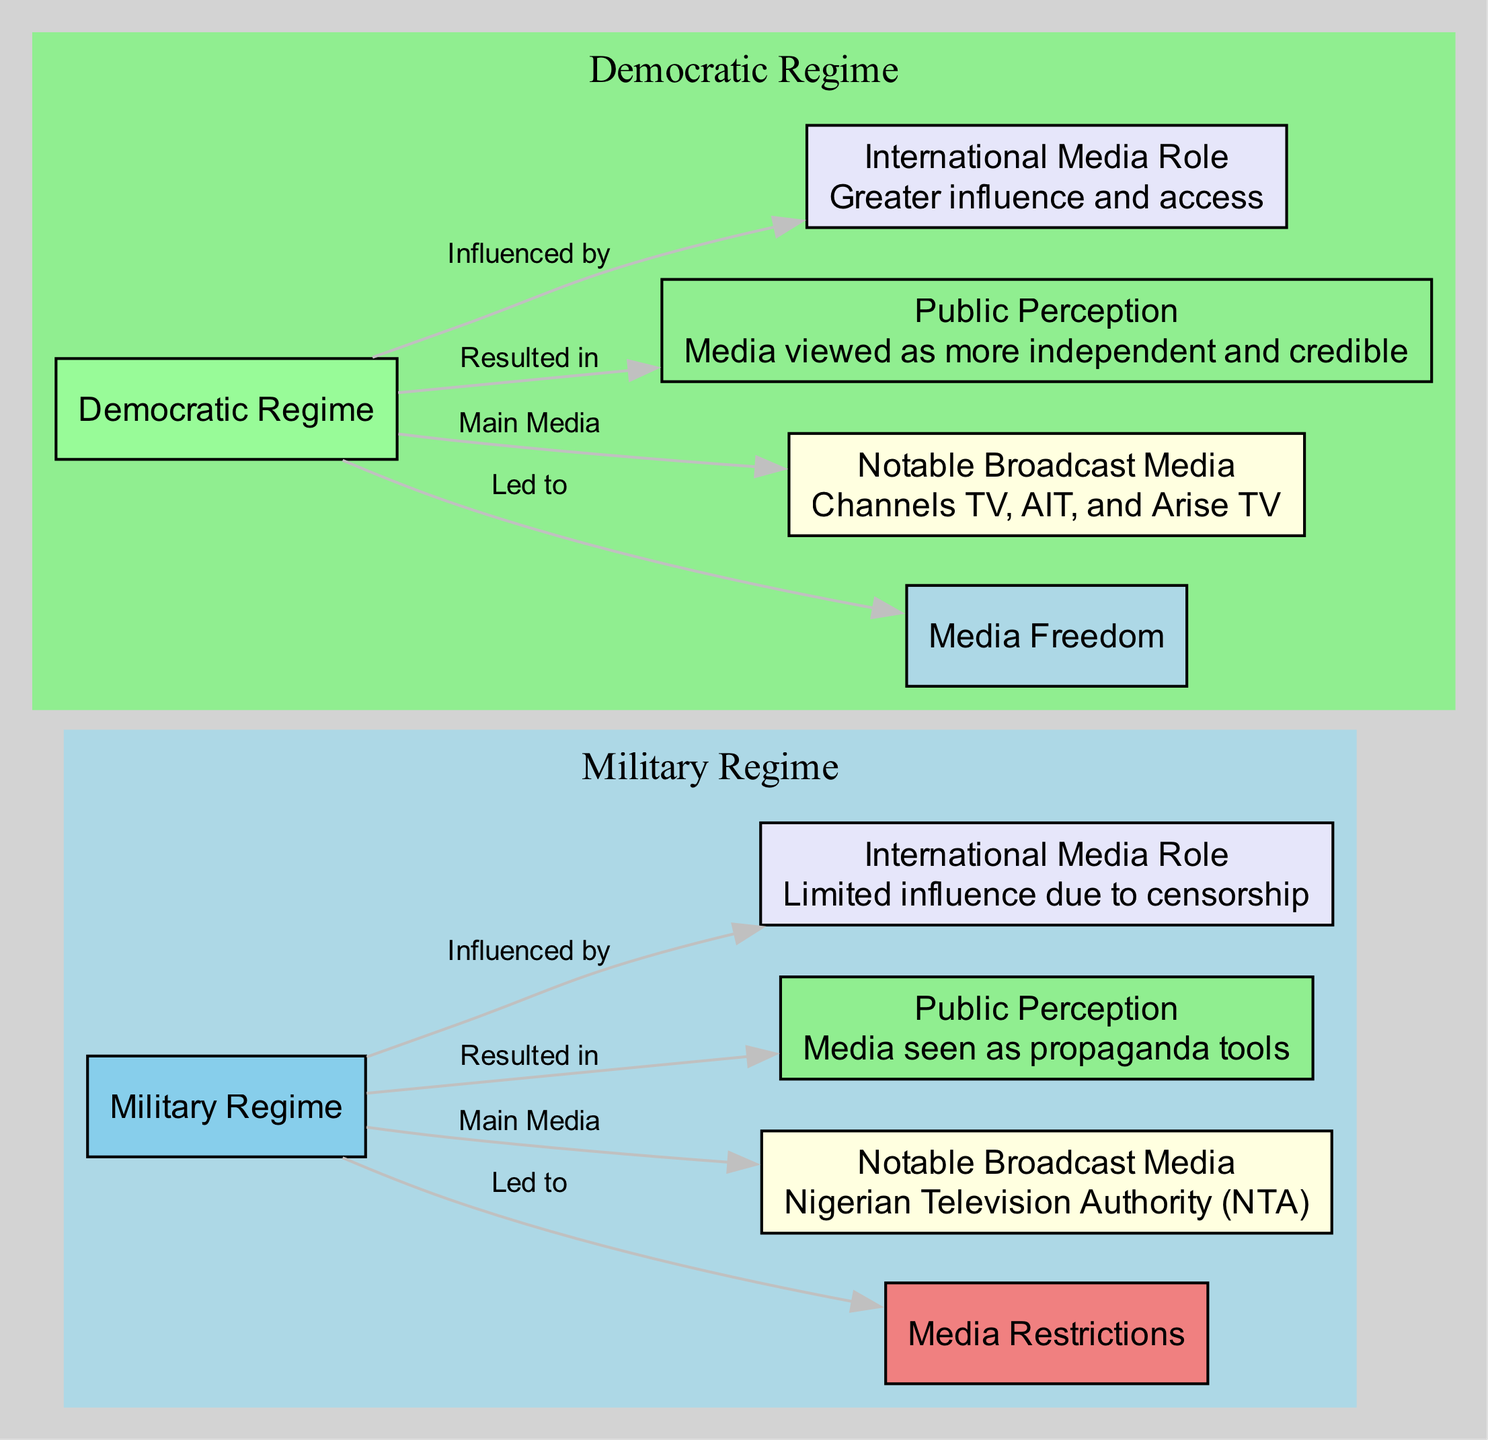What is the main media during the military regime? The diagram clearly indicates that the Nigerian Television Authority (NTA) is identified as the main media during the military regime. This is explicitly shown in the node labeled "Notable Broadcast Media" under the "Military Regime" cluster.
Answer: Nigerian Television Authority (NTA) How many notable broadcast media are listed for the democratic regime? The diagram indicates that there are three notable broadcast media listed under the democratic regime: Channels TV, AIT, and Arise TV. This is presented in the "Notable Broadcast Media" node within the "Democratic Regime" cluster.
Answer: Three What type of media restrictions are present during the military regime? The diagram specifies "Severe censorship and control of broadcast media" as the type of restrictions present during the military regime, clearly stated in the "Media Restrictions" node linked to the "Military Regime."
Answer: Severe censorship and control Which perception of media is associated with the democratic regime? The diagram describes the public perception of media during the democratic regime as "Media viewed as more independent and credible." This can be found in the "Public Perception" node linked to the "Democratic Regime."
Answer: More independent and credible What is the relationship between the military regime and international media role? The diagram shows that the role of international media during the military regime is "Limited influence due to censorship." This indicates a direct influence relationship between the military regime and its constrained international media role.
Answer: Limited influence due to censorship How does the democratic regime affect media freedom? The diagram indicates that the democratic regime leads to increased freedom and diversity in broadcast media. This connection is represented in the edge from the "Democratic Regime" node to the "Media Freedom" node.
Answer: Increased freedom and diversity What is the public perception of media during the military regime? The diagram indicates that media during the military regime is seen as propaganda tools, noted in the "Public Perception" node associated with the military regime.
Answer: Propaganda tools What type of media role is influenced by the democratic regime? The diagram states that the international media role during the democratic regime has a "Greater influence and access." This relationship is depicted in the corresponding node connected to the "Democratic Regime."
Answer: Greater influence and access 